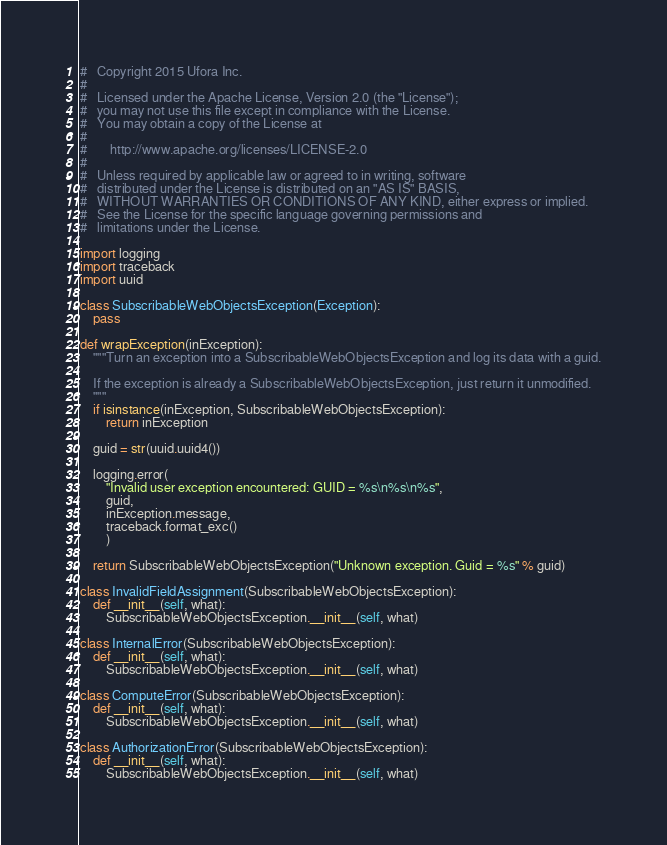Convert code to text. <code><loc_0><loc_0><loc_500><loc_500><_Python_>#   Copyright 2015 Ufora Inc.
#
#   Licensed under the Apache License, Version 2.0 (the "License");
#   you may not use this file except in compliance with the License.
#   You may obtain a copy of the License at
#
#       http://www.apache.org/licenses/LICENSE-2.0
#
#   Unless required by applicable law or agreed to in writing, software
#   distributed under the License is distributed on an "AS IS" BASIS,
#   WITHOUT WARRANTIES OR CONDITIONS OF ANY KIND, either express or implied.
#   See the License for the specific language governing permissions and
#   limitations under the License.

import logging
import traceback
import uuid

class SubscribableWebObjectsException(Exception):
    pass

def wrapException(inException):
    """Turn an exception into a SubscribableWebObjectsException and log its data with a guid.

    If the exception is already a SubscribableWebObjectsException, just return it unmodified.
    """
    if isinstance(inException, SubscribableWebObjectsException):
        return inException

    guid = str(uuid.uuid4())

    logging.error(
        "Invalid user exception encountered: GUID = %s\n%s\n%s",
        guid,
        inException.message,
        traceback.format_exc()
        )

    return SubscribableWebObjectsException("Unknown exception. Guid = %s" % guid)

class InvalidFieldAssignment(SubscribableWebObjectsException):
    def __init__(self, what):
        SubscribableWebObjectsException.__init__(self, what)

class InternalError(SubscribableWebObjectsException):
    def __init__(self, what):
        SubscribableWebObjectsException.__init__(self, what)

class ComputeError(SubscribableWebObjectsException):
    def __init__(self, what):
        SubscribableWebObjectsException.__init__(self, what)

class AuthorizationError(SubscribableWebObjectsException):
    def __init__(self, what):
        SubscribableWebObjectsException.__init__(self, what)

</code> 